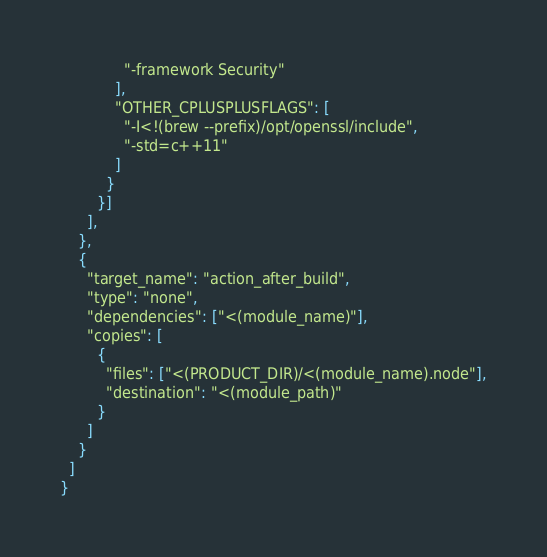<code> <loc_0><loc_0><loc_500><loc_500><_Python_>              "-framework Security"
            ],
            "OTHER_CPLUSPLUSFLAGS": [
              "-I<!(brew --prefix)/opt/openssl/include",
              "-std=c++11"
            ]
          }
      	}]
      ],
    },
    {
      "target_name": "action_after_build",
      "type": "none",
      "dependencies": ["<(module_name)"],
      "copies": [
        {
          "files": ["<(PRODUCT_DIR)/<(module_name).node"],
          "destination": "<(module_path)"
        }
      ]
    }
  ]
}
</code> 